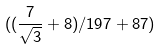Convert formula to latex. <formula><loc_0><loc_0><loc_500><loc_500>( ( \frac { 7 } { \sqrt { 3 } } + 8 ) / 1 9 7 + 8 7 )</formula> 